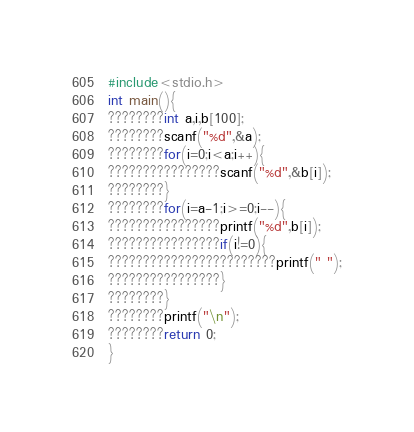Convert code to text. <code><loc_0><loc_0><loc_500><loc_500><_C_>#include<stdio.h>
int main(){
????????int a,i,b[100];
????????scanf("%d",&a);
????????for(i=0;i<a;i++){
????????????????scanf("%d",&b[i]);
????????}
????????for(i=a-1;i>=0;i--){
????????????????printf("%d",b[i]);
????????????????if(i!=0){
????????????????????????printf(" ");
????????????????}
????????}
????????printf("\n");
????????return 0;
}</code> 